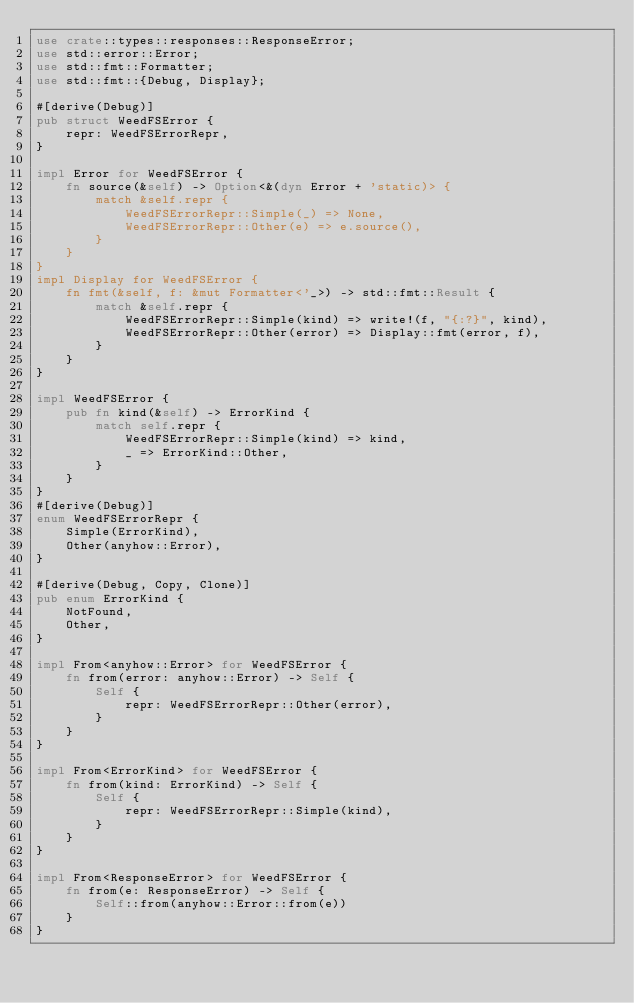<code> <loc_0><loc_0><loc_500><loc_500><_Rust_>use crate::types::responses::ResponseError;
use std::error::Error;
use std::fmt::Formatter;
use std::fmt::{Debug, Display};

#[derive(Debug)]
pub struct WeedFSError {
    repr: WeedFSErrorRepr,
}

impl Error for WeedFSError {
    fn source(&self) -> Option<&(dyn Error + 'static)> {
        match &self.repr {
            WeedFSErrorRepr::Simple(_) => None,
            WeedFSErrorRepr::Other(e) => e.source(),
        }
    }
}
impl Display for WeedFSError {
    fn fmt(&self, f: &mut Formatter<'_>) -> std::fmt::Result {
        match &self.repr {
            WeedFSErrorRepr::Simple(kind) => write!(f, "{:?}", kind),
            WeedFSErrorRepr::Other(error) => Display::fmt(error, f),
        }
    }
}

impl WeedFSError {
    pub fn kind(&self) -> ErrorKind {
        match self.repr {
            WeedFSErrorRepr::Simple(kind) => kind,
            _ => ErrorKind::Other,
        }
    }
}
#[derive(Debug)]
enum WeedFSErrorRepr {
    Simple(ErrorKind),
    Other(anyhow::Error),
}

#[derive(Debug, Copy, Clone)]
pub enum ErrorKind {
    NotFound,
    Other,
}

impl From<anyhow::Error> for WeedFSError {
    fn from(error: anyhow::Error) -> Self {
        Self {
            repr: WeedFSErrorRepr::Other(error),
        }
    }
}

impl From<ErrorKind> for WeedFSError {
    fn from(kind: ErrorKind) -> Self {
        Self {
            repr: WeedFSErrorRepr::Simple(kind),
        }
    }
}

impl From<ResponseError> for WeedFSError {
    fn from(e: ResponseError) -> Self {
        Self::from(anyhow::Error::from(e))
    }
}
</code> 